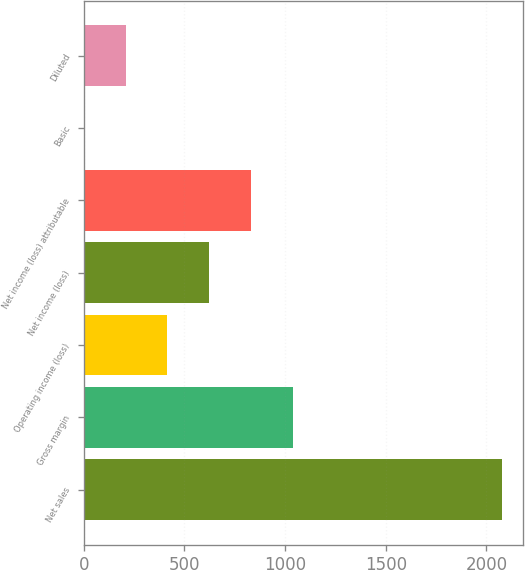Convert chart. <chart><loc_0><loc_0><loc_500><loc_500><bar_chart><fcel>Net sales<fcel>Gross margin<fcel>Operating income (loss)<fcel>Net income (loss)<fcel>Net income (loss) attributable<fcel>Basic<fcel>Diluted<nl><fcel>2078<fcel>1039.13<fcel>415.82<fcel>623.59<fcel>831.36<fcel>0.28<fcel>208.05<nl></chart> 